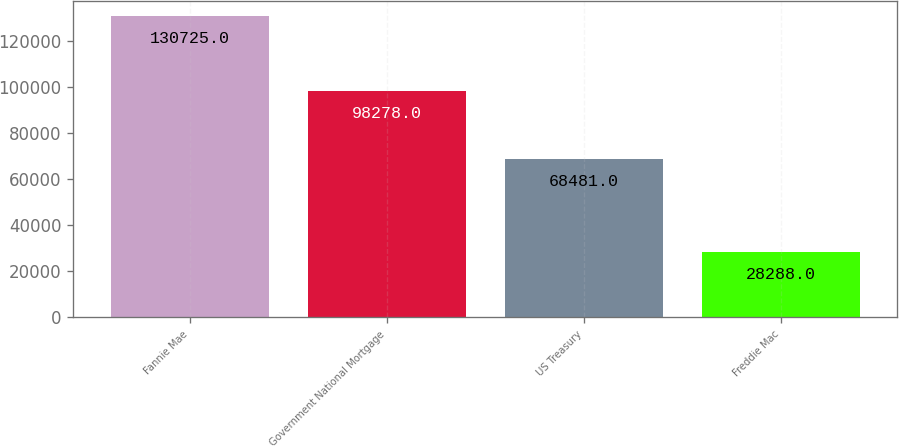Convert chart. <chart><loc_0><loc_0><loc_500><loc_500><bar_chart><fcel>Fannie Mae<fcel>Government National Mortgage<fcel>US Treasury<fcel>Freddie Mac<nl><fcel>130725<fcel>98278<fcel>68481<fcel>28288<nl></chart> 